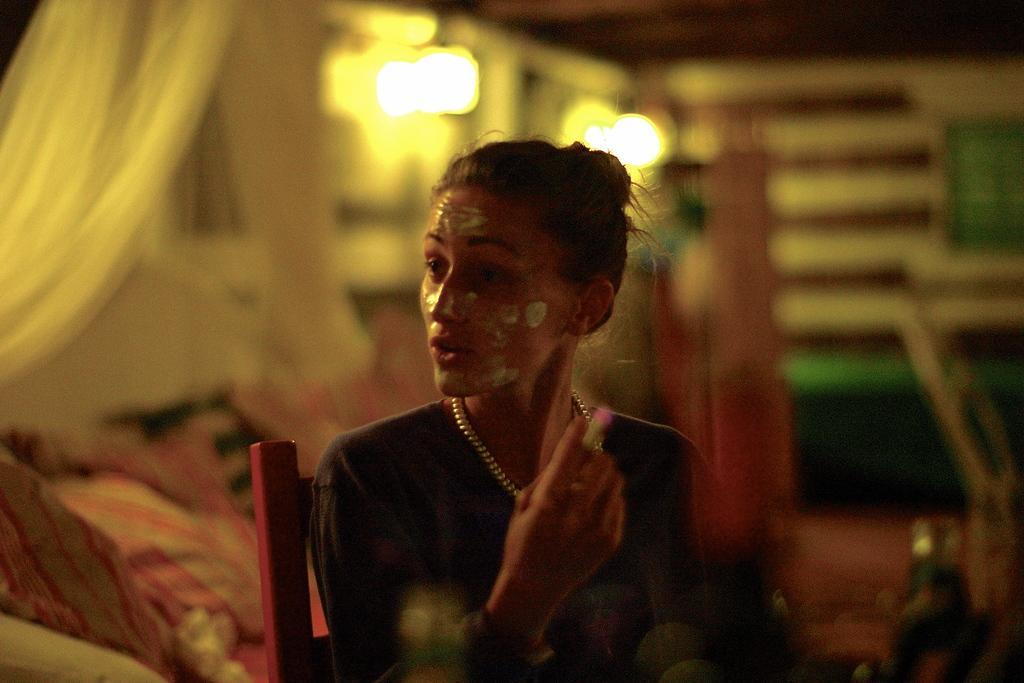Can you describe this image briefly? In this image there is a lady sitting on a chair, in the background it is blurred. 